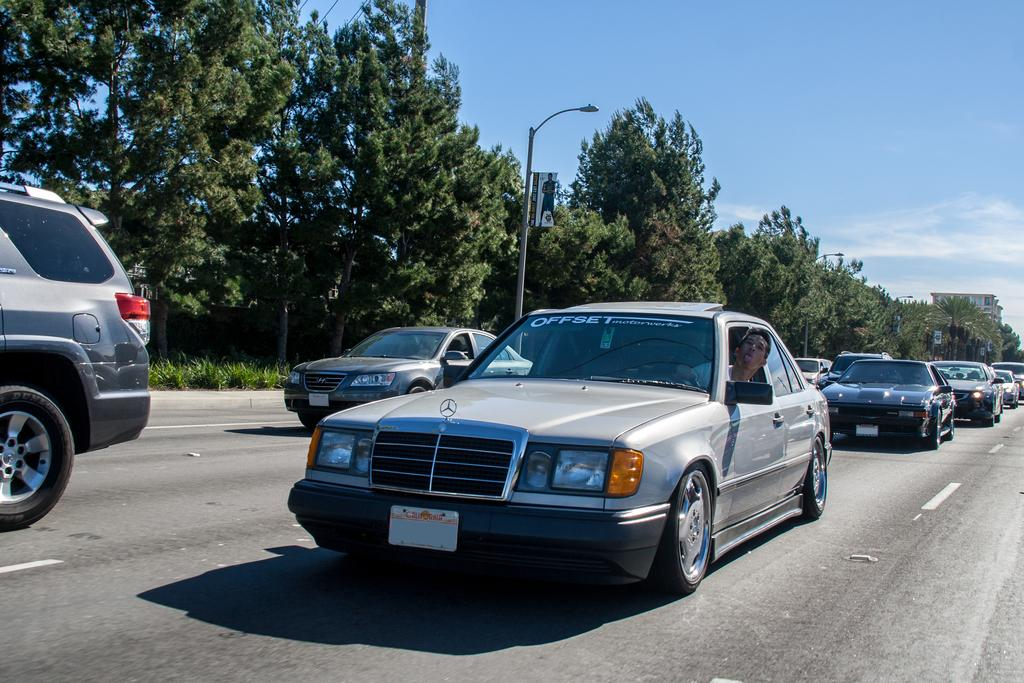What is happening in the foreground of the picture? There are cars moving on the road in the foreground of the picture. What can be seen in the background of the picture? There are trees, poles, plants, a building, and the sky visible in the background of the picture. Can you describe the sky in the picture? The sky is visible in the background of the picture, and there is a cloud present. What is the opinion of the drug on the jewel in the picture? There is no drug or jewel present in the picture; it features cars moving on the road, trees, poles, plants, a building, and the sky. 